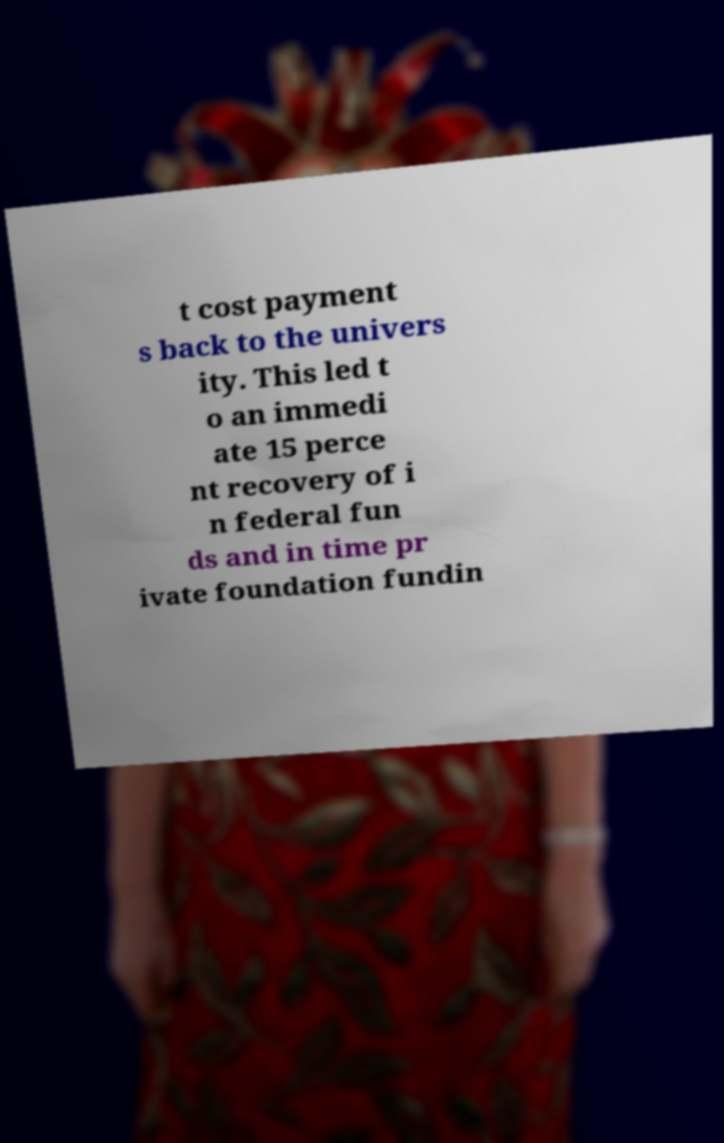Please identify and transcribe the text found in this image. t cost payment s back to the univers ity. This led t o an immedi ate 15 perce nt recovery of i n federal fun ds and in time pr ivate foundation fundin 